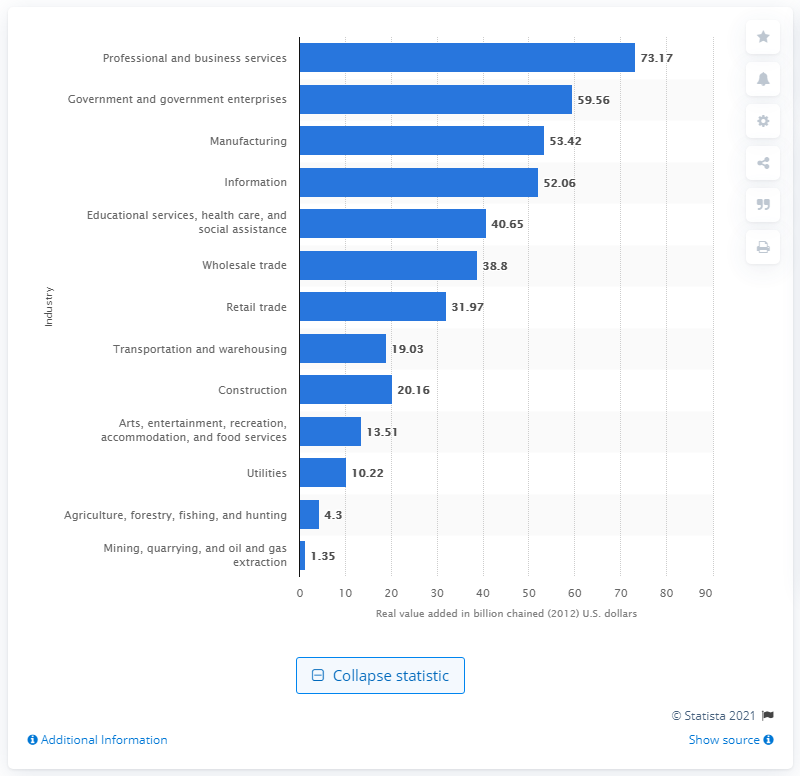Give some essential details in this illustration. In 2012, the utilities industry contributed a total value of $10.22 billion to Georgia's Gross Domestic Product (GDP). 